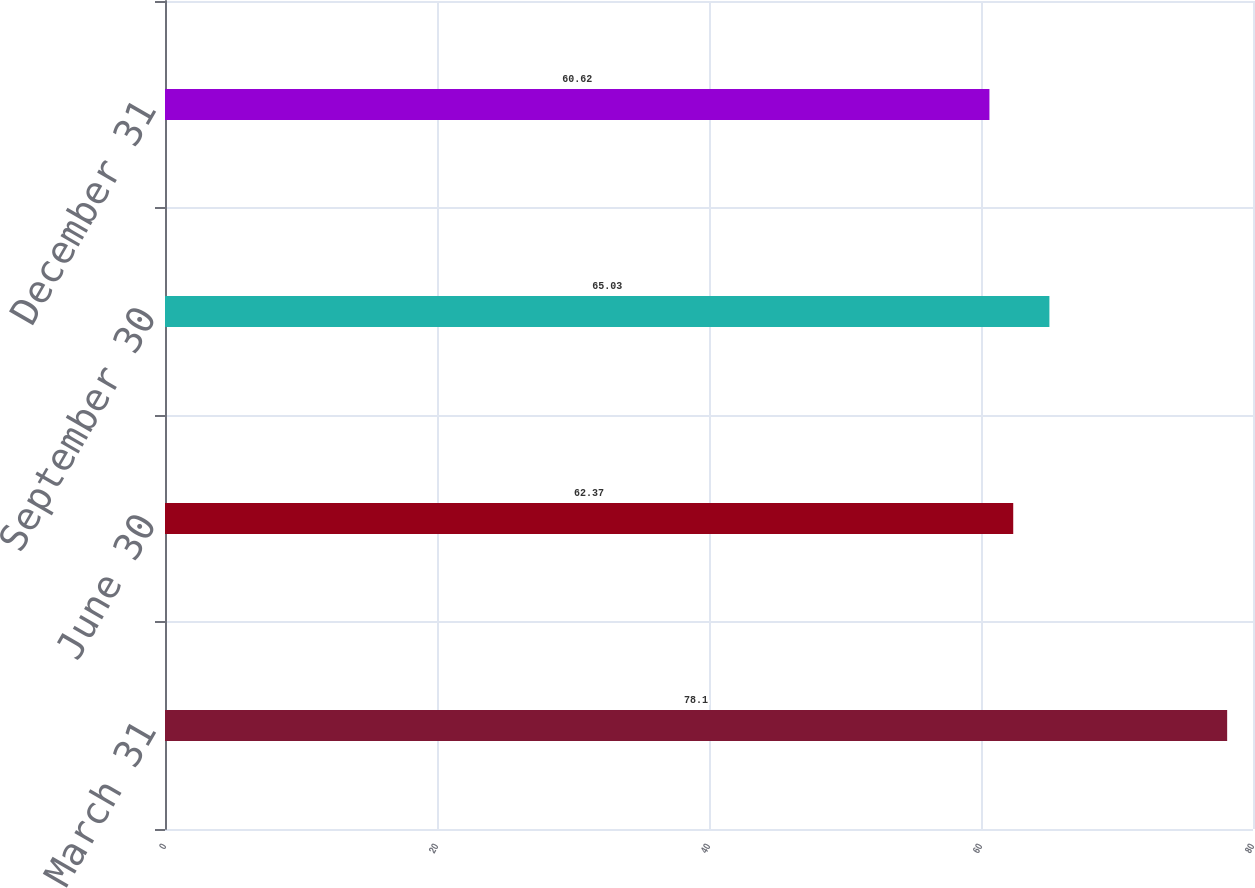Convert chart to OTSL. <chart><loc_0><loc_0><loc_500><loc_500><bar_chart><fcel>March 31<fcel>June 30<fcel>September 30<fcel>December 31<nl><fcel>78.1<fcel>62.37<fcel>65.03<fcel>60.62<nl></chart> 